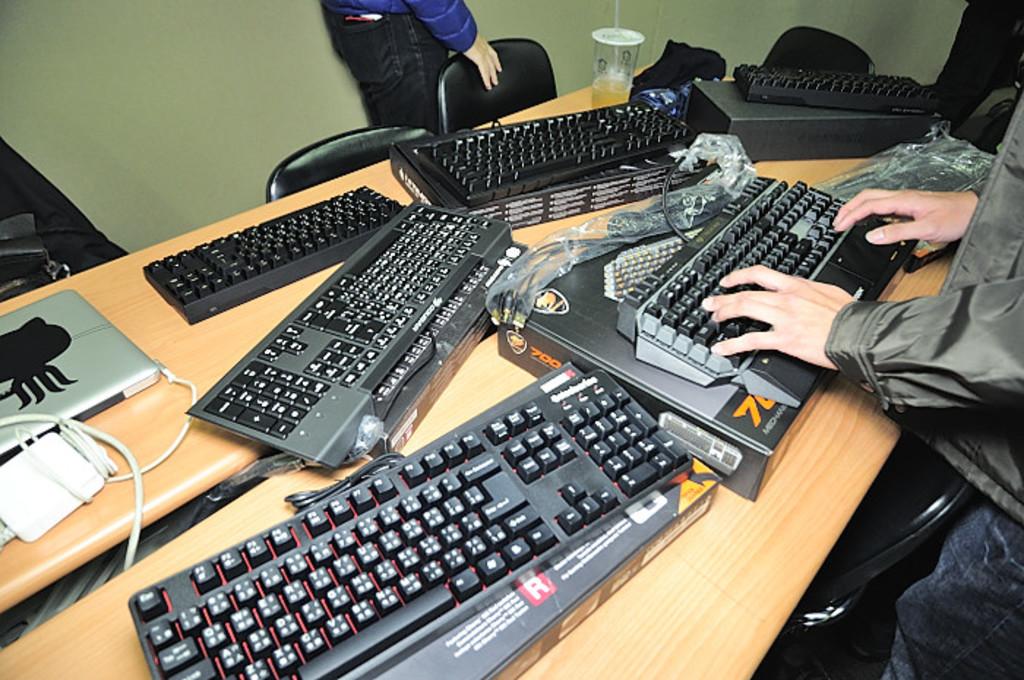What is the letter in white on the box in the red square?
Your response must be concise. R. 